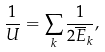<formula> <loc_0><loc_0><loc_500><loc_500>\frac { 1 } { U } = \sum _ { k } \frac { 1 } { 2 \overline { E } _ { k } } ,</formula> 